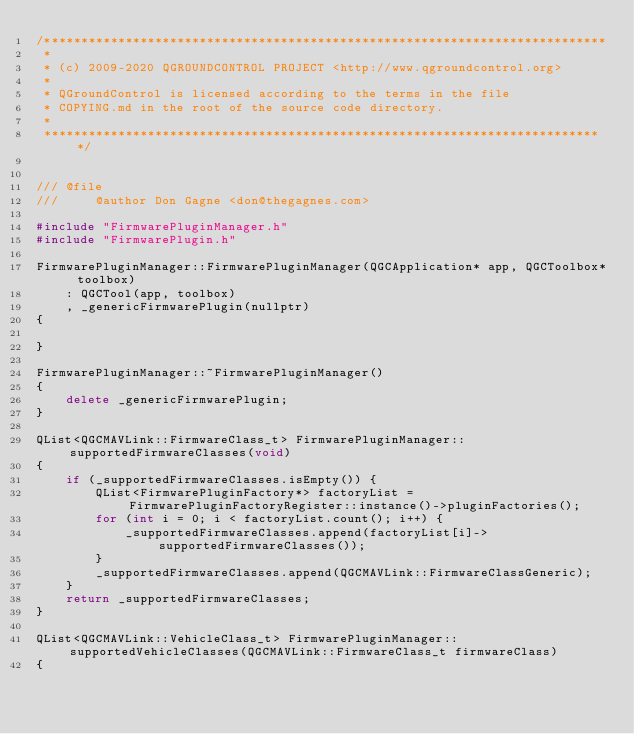Convert code to text. <code><loc_0><loc_0><loc_500><loc_500><_C++_>/****************************************************************************
 *
 * (c) 2009-2020 QGROUNDCONTROL PROJECT <http://www.qgroundcontrol.org>
 *
 * QGroundControl is licensed according to the terms in the file
 * COPYING.md in the root of the source code directory.
 *
 ****************************************************************************/


/// @file
///     @author Don Gagne <don@thegagnes.com>

#include "FirmwarePluginManager.h"
#include "FirmwarePlugin.h"

FirmwarePluginManager::FirmwarePluginManager(QGCApplication* app, QGCToolbox* toolbox)
    : QGCTool(app, toolbox)
    , _genericFirmwarePlugin(nullptr)
{

}

FirmwarePluginManager::~FirmwarePluginManager()
{
    delete _genericFirmwarePlugin;
}

QList<QGCMAVLink::FirmwareClass_t> FirmwarePluginManager::supportedFirmwareClasses(void)
{
    if (_supportedFirmwareClasses.isEmpty()) {
        QList<FirmwarePluginFactory*> factoryList = FirmwarePluginFactoryRegister::instance()->pluginFactories();
        for (int i = 0; i < factoryList.count(); i++) {
            _supportedFirmwareClasses.append(factoryList[i]->supportedFirmwareClasses());
        }
        _supportedFirmwareClasses.append(QGCMAVLink::FirmwareClassGeneric);
    }
    return _supportedFirmwareClasses;
}

QList<QGCMAVLink::VehicleClass_t> FirmwarePluginManager::supportedVehicleClasses(QGCMAVLink::FirmwareClass_t firmwareClass)
{</code> 